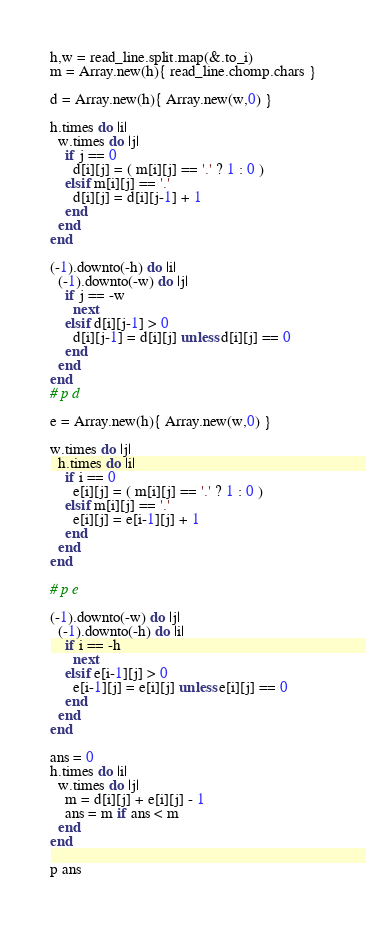Convert code to text. <code><loc_0><loc_0><loc_500><loc_500><_Crystal_>h,w = read_line.split.map(&.to_i)
m = Array.new(h){ read_line.chomp.chars }

d = Array.new(h){ Array.new(w,0) }

h.times do |i|
  w.times do |j|
    if j == 0
      d[i][j] = ( m[i][j] == '.' ? 1 : 0 )
    elsif m[i][j] == '.'
      d[i][j] = d[i][j-1] + 1
    end
  end
end

(-1).downto(-h) do |i|
  (-1).downto(-w) do |j|
    if j == -w
      next
    elsif d[i][j-1] > 0
      d[i][j-1] = d[i][j] unless d[i][j] == 0
    end
  end
end
# p d

e = Array.new(h){ Array.new(w,0) }

w.times do |j|
  h.times do |i|
    if i == 0
      e[i][j] = ( m[i][j] == '.' ? 1 : 0 )
    elsif m[i][j] == '.'
      e[i][j] = e[i-1][j] + 1
    end
  end
end

# p e

(-1).downto(-w) do |j|
  (-1).downto(-h) do |i|
    if i == -h
      next
    elsif e[i-1][j] > 0
      e[i-1][j] = e[i][j] unless e[i][j] == 0
    end
  end
end

ans = 0
h.times do |i|
  w.times do |j|
    m = d[i][j] + e[i][j] - 1
    ans = m if ans < m 
  end
end

p ans</code> 